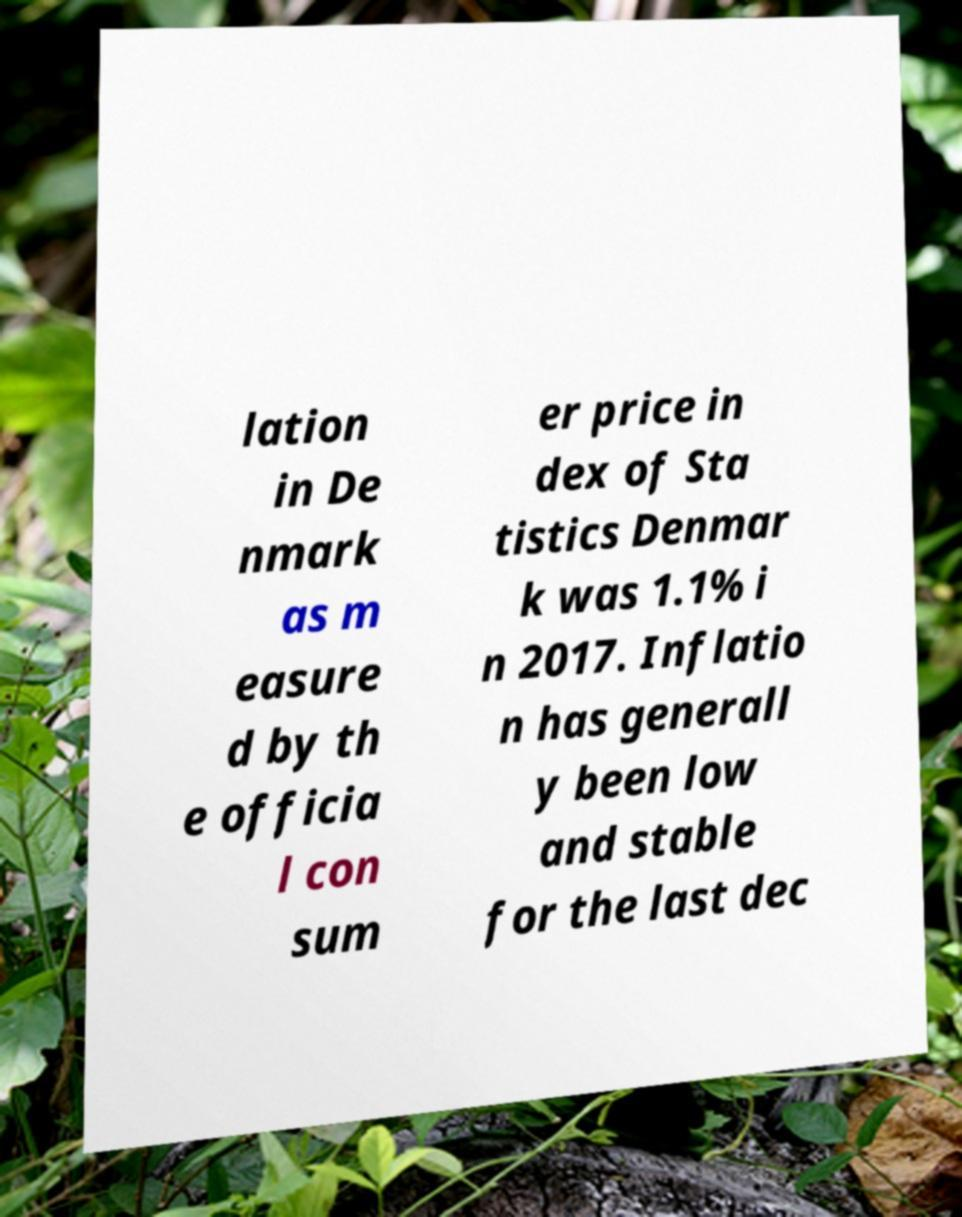Please read and relay the text visible in this image. What does it say? lation in De nmark as m easure d by th e officia l con sum er price in dex of Sta tistics Denmar k was 1.1% i n 2017. Inflatio n has generall y been low and stable for the last dec 